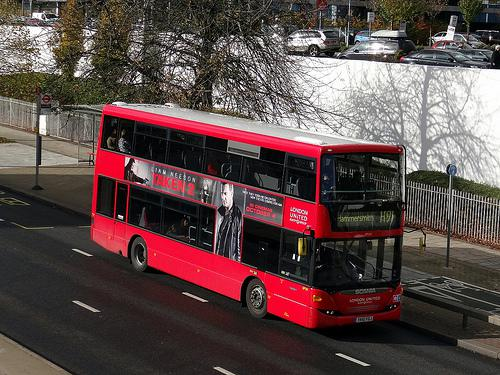Question: where was this photo taken?
Choices:
A. Under the sign.
B. Near the corner.
C. Near a bus stop.
D. On the sidewalk.
Answer with the letter. Answer: C Question: how is the photo?
Choices:
A. Crisp.
B. Bright.
C. Clear.
D. Colorful.
Answer with the letter. Answer: C Question: what is present?
Choices:
A. A truck.
B. A van.
C. A bus.
D. A car.
Answer with the letter. Answer: C 